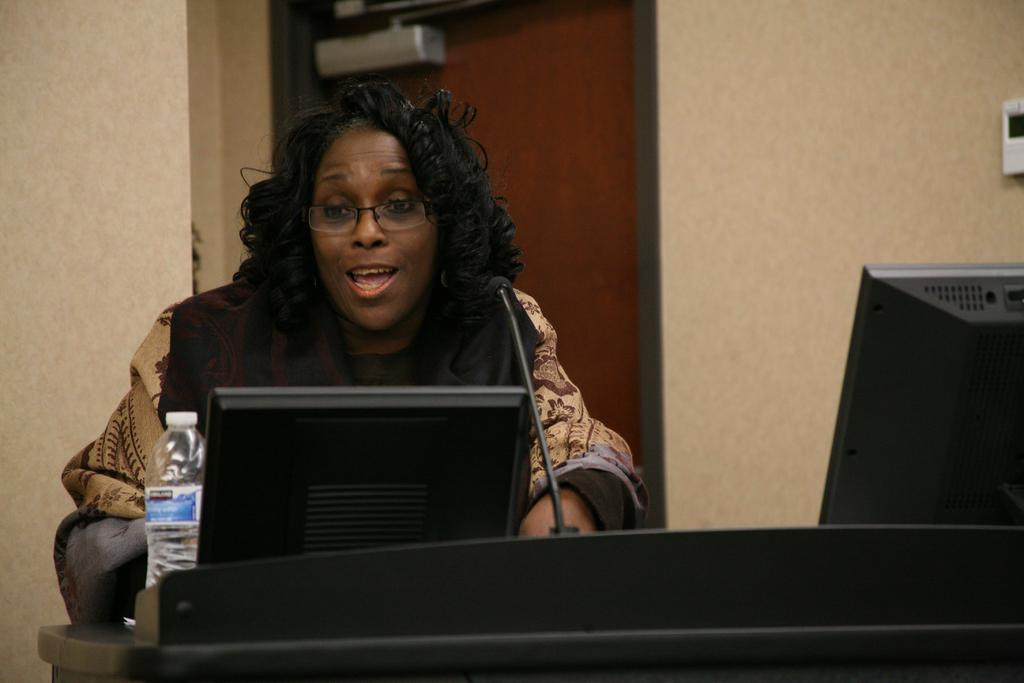Who is present in the image? There is a woman in the image. What is in front of the woman? There is a table in front of the woman. What can be seen on the table? There are monitors, a bottle, and a mic on the table. What is visible in the background of the image? There is a door and a wall in the background of the image. What type of pump is visible on the table in the image? There is no pump present on the table in the image. What color is the linen draped over the monitors in the image? There is no linen draped over the monitors in the image. 